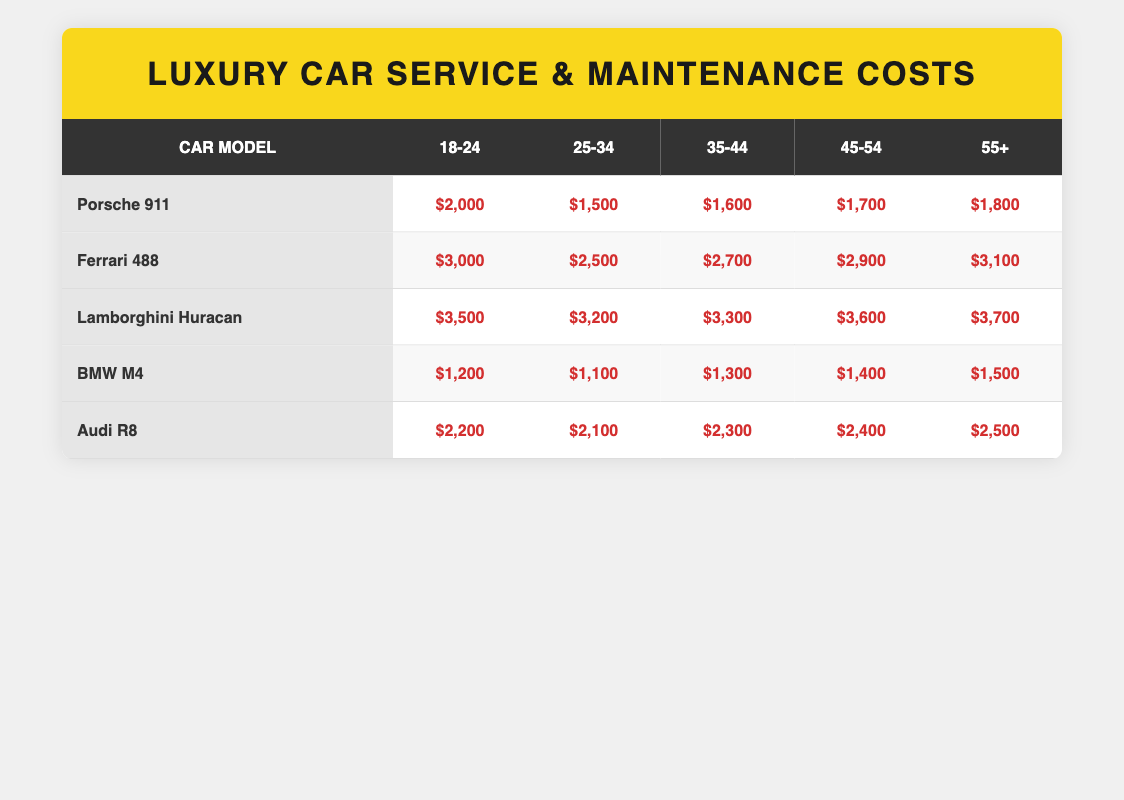What is the service and maintenance cost for a Porsche 911 for the age group 25-34? From the table, the service and maintenance cost for a Porsche 911 in the 25-34 age group is listed directly as $1,500.
Answer: $1,500 Which car model has the highest annual maintenance cost for the age group 18-24? By examining the values in the 18-24 column, the Lamborghini Huracan has the highest cost at $3,500 compared to Porsche 911 ($2,000), Ferrari 488 ($3,000), BMW M4 ($1,200), and Audi R8 ($2,200).
Answer: Lamborghini Huracan What is the total service cost for Ferrari 488 across all age groups? The service costs for Ferrari 488 by age group are: $3,000 (18-24) + $2,500 (25-34) + $2,700 (35-44) + $2,900 (45-54) + $3,100 (55+) = $14,200.
Answer: $14,200 Is the annual maintenance cost for a BMW M4 in the 45-54 age group higher than that of an Audi R8 in the same age group? For BMW M4, the cost is $1,400. For Audi R8, it is $2,400. Comparing these values, $1,400 is less than $2,400; therefore, the maintenance cost for BMW M4 is not higher.
Answer: No What is the average maintenance cost for the Lamborghini Huracan across all age groups? The yearly costs for Lamborghini Huracan are: $3,500, $3,200, $3,300, $3,600, and $3,700. Adding these gives $17,300. There are 5 age groups, so the average is $17,300 divided by 5, which equals $3,460.
Answer: $3,460 How much more does the oldest age group (55+) spend on maintenance for a Ferrari 488 compared to a BMW M4? For the 55+ age group, Ferrari 488 costs $3,100 and BMW M4 costs $1,500. The difference is $3,100 - $1,500 = $1,600, indicating that Ferrari 488 has a significantly higher cost.
Answer: $1,600 Which age group has the lowest service and maintenance cost for any car model? Looking through all age groups and models, the lowest cost is $1,100 for the BMW M4 in the 25-34 age group, which is lower than all other costs in the table.
Answer: 25-34 age group (BMW M4) at $1,100 Is the maintenance cost for an Audi R8 in the 35-44 age group equal to that of a Porsche 911 for the same age group? The maintenance cost for Audi R8 in the 35-44 age group is $2,300, and for Porsche 911, it is $1,600. Since $2,300 is not equal to $1,600, the costs are not the same.
Answer: No 